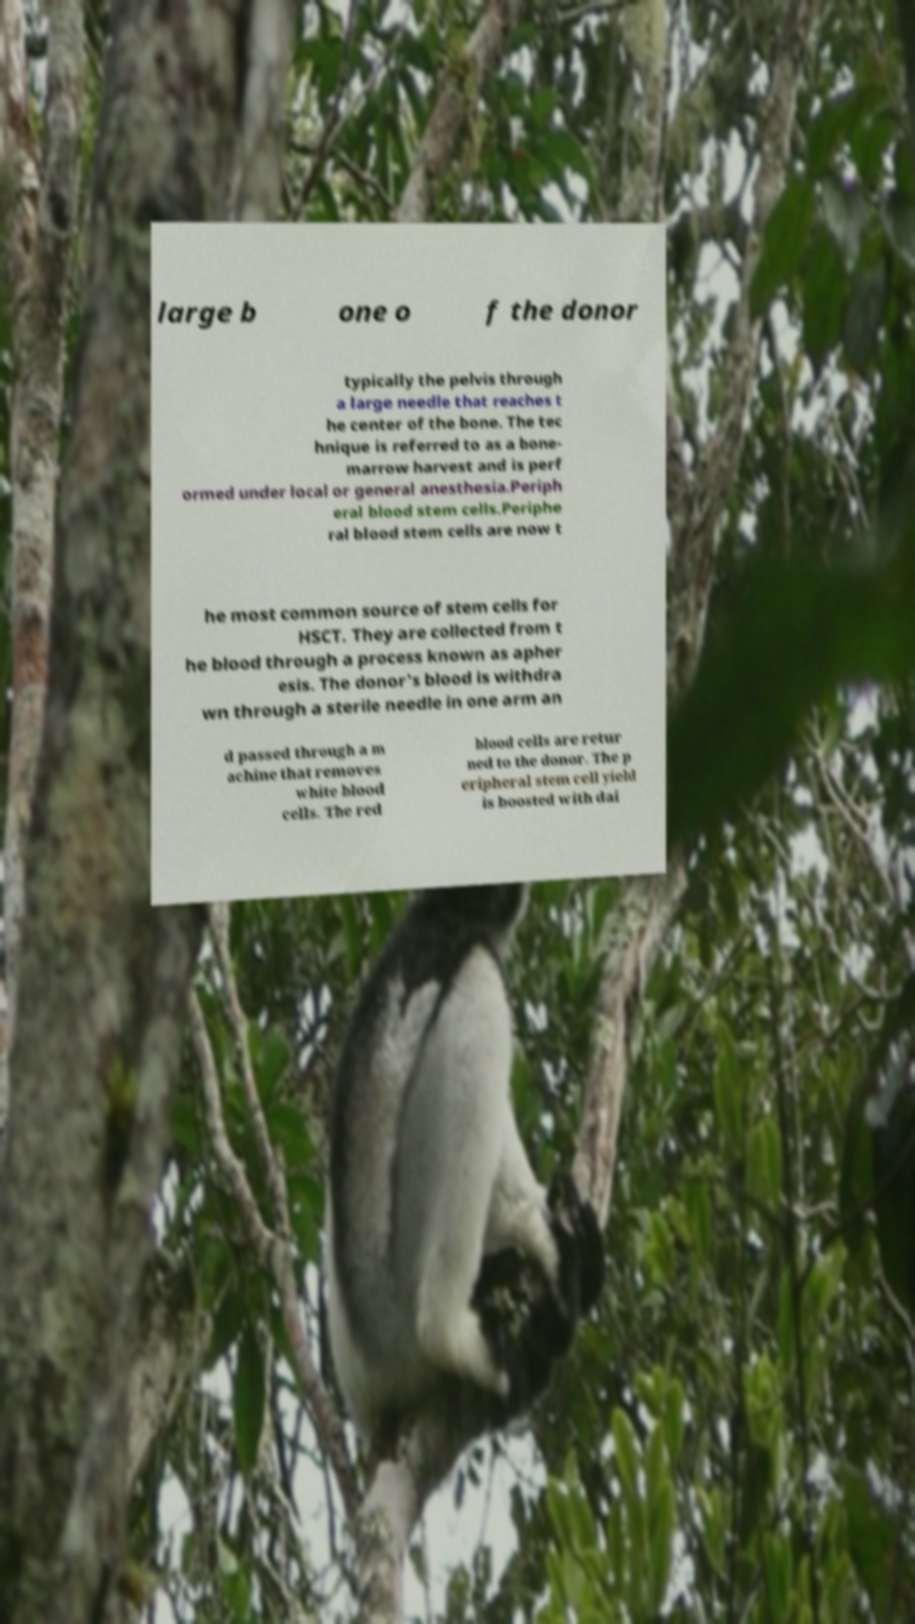I need the written content from this picture converted into text. Can you do that? large b one o f the donor typically the pelvis through a large needle that reaches t he center of the bone. The tec hnique is referred to as a bone- marrow harvest and is perf ormed under local or general anesthesia.Periph eral blood stem cells.Periphe ral blood stem cells are now t he most common source of stem cells for HSCT. They are collected from t he blood through a process known as apher esis. The donor's blood is withdra wn through a sterile needle in one arm an d passed through a m achine that removes white blood cells. The red blood cells are retur ned to the donor. The p eripheral stem cell yield is boosted with dai 